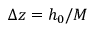Convert formula to latex. <formula><loc_0><loc_0><loc_500><loc_500>\Delta z = h _ { 0 } / M</formula> 